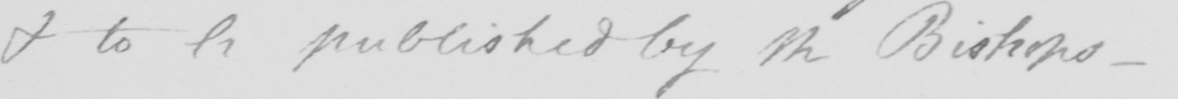Can you read and transcribe this handwriting? & to be published by the Bishops . 